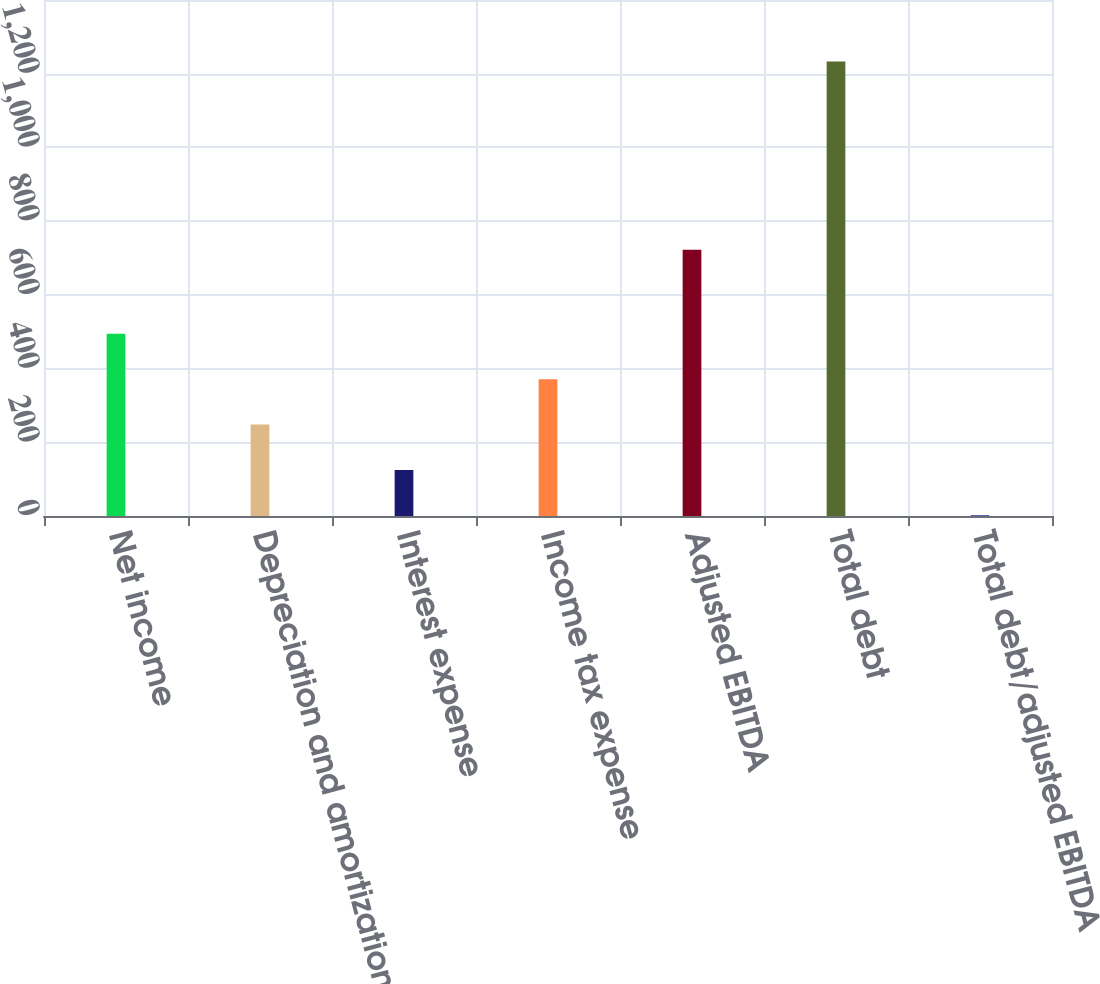Convert chart to OTSL. <chart><loc_0><loc_0><loc_500><loc_500><bar_chart><fcel>Net income<fcel>Depreciation and amortization<fcel>Interest expense<fcel>Income tax expense<fcel>Adjusted EBITDA<fcel>Total debt<fcel>Total debt/adjusted EBITDA<nl><fcel>494.27<fcel>247.99<fcel>124.85<fcel>371.13<fcel>722.2<fcel>1233.1<fcel>1.71<nl></chart> 